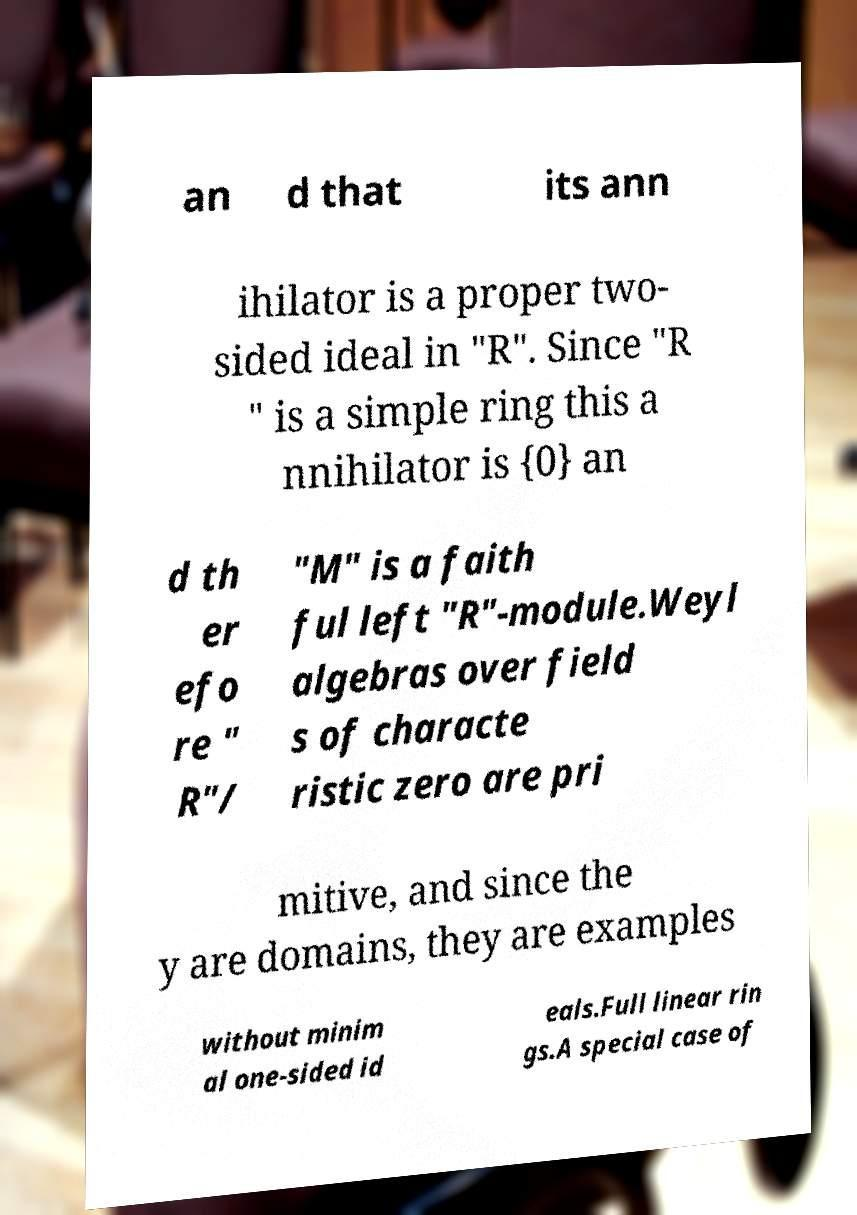There's text embedded in this image that I need extracted. Can you transcribe it verbatim? an d that its ann ihilator is a proper two- sided ideal in "R". Since "R " is a simple ring this a nnihilator is {0} an d th er efo re " R"/ "M" is a faith ful left "R"-module.Weyl algebras over field s of characte ristic zero are pri mitive, and since the y are domains, they are examples without minim al one-sided id eals.Full linear rin gs.A special case of 